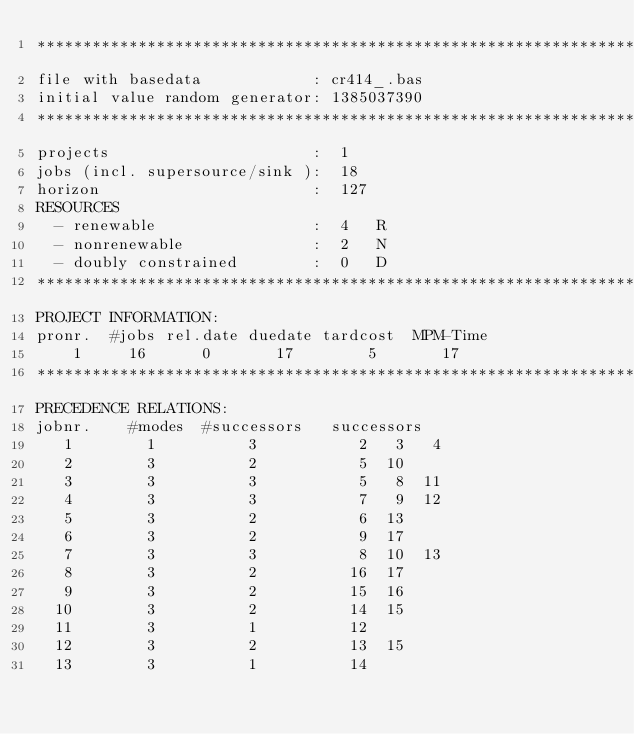Convert code to text. <code><loc_0><loc_0><loc_500><loc_500><_ObjectiveC_>************************************************************************
file with basedata            : cr414_.bas
initial value random generator: 1385037390
************************************************************************
projects                      :  1
jobs (incl. supersource/sink ):  18
horizon                       :  127
RESOURCES
  - renewable                 :  4   R
  - nonrenewable              :  2   N
  - doubly constrained        :  0   D
************************************************************************
PROJECT INFORMATION:
pronr.  #jobs rel.date duedate tardcost  MPM-Time
    1     16      0       17        5       17
************************************************************************
PRECEDENCE RELATIONS:
jobnr.    #modes  #successors   successors
   1        1          3           2   3   4
   2        3          2           5  10
   3        3          3           5   8  11
   4        3          3           7   9  12
   5        3          2           6  13
   6        3          2           9  17
   7        3          3           8  10  13
   8        3          2          16  17
   9        3          2          15  16
  10        3          2          14  15
  11        3          1          12
  12        3          2          13  15
  13        3          1          14</code> 